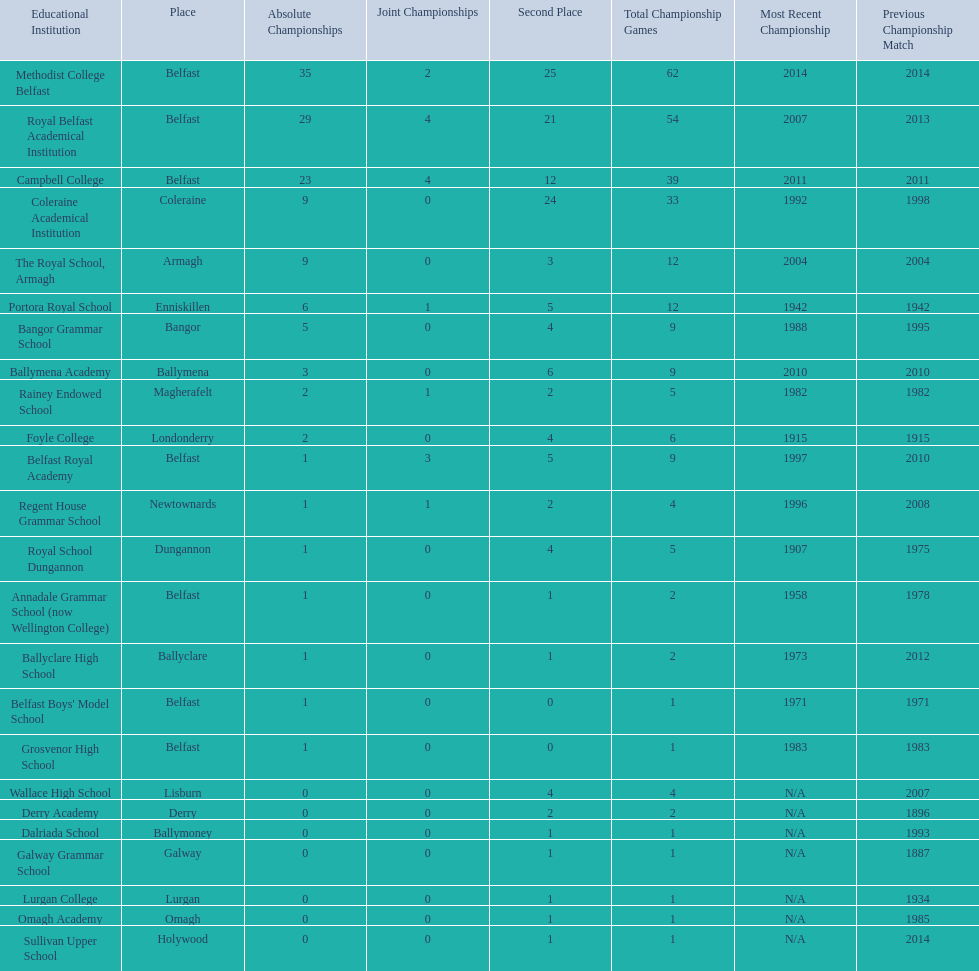Which colleges participated in the ulster's schools' cup? Methodist College Belfast, Royal Belfast Academical Institution, Campbell College, Coleraine Academical Institution, The Royal School, Armagh, Portora Royal School, Bangor Grammar School, Ballymena Academy, Rainey Endowed School, Foyle College, Belfast Royal Academy, Regent House Grammar School, Royal School Dungannon, Annadale Grammar School (now Wellington College), Ballyclare High School, Belfast Boys' Model School, Grosvenor High School, Wallace High School, Derry Academy, Dalriada School, Galway Grammar School, Lurgan College, Omagh Academy, Sullivan Upper School. Of these, which are from belfast? Methodist College Belfast, Royal Belfast Academical Institution, Campbell College, Belfast Royal Academy, Annadale Grammar School (now Wellington College), Belfast Boys' Model School, Grosvenor High School. Of these, which have more than 20 outright titles? Methodist College Belfast, Royal Belfast Academical Institution, Campbell College. Which of these have the fewest runners-up? Campbell College. 